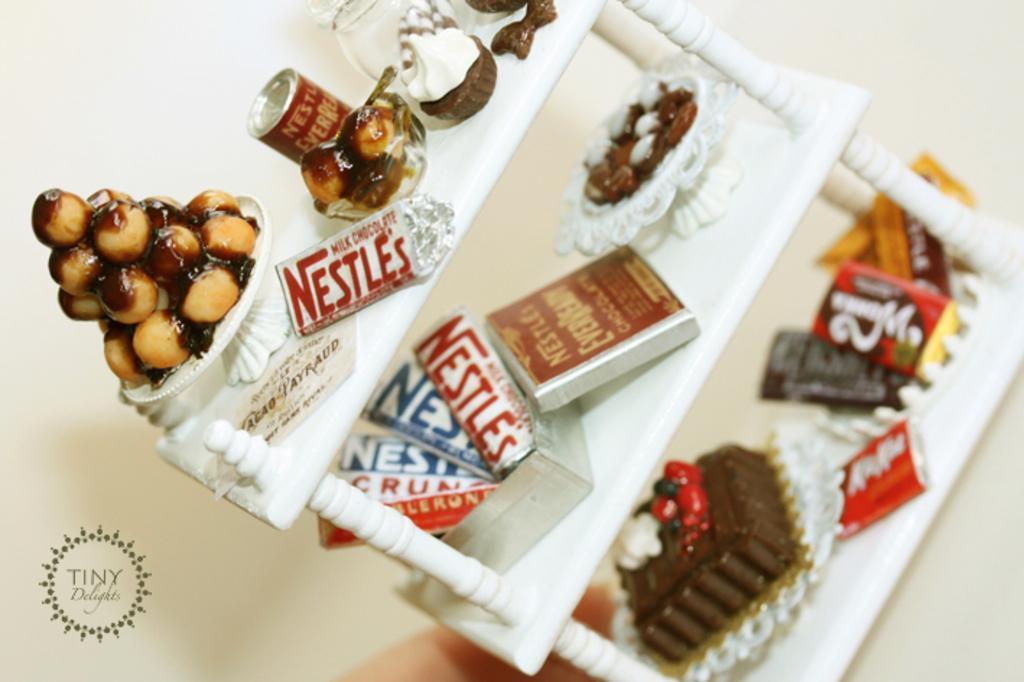In one or two sentences, can you explain what this image depicts? Here I can see a table on which few boxes, jar, cock-tin, cake, chocolates, bowls and some other food items are placed. At the bottom, I can see a person's hand. In the bottom left-hand corner there is some text. 